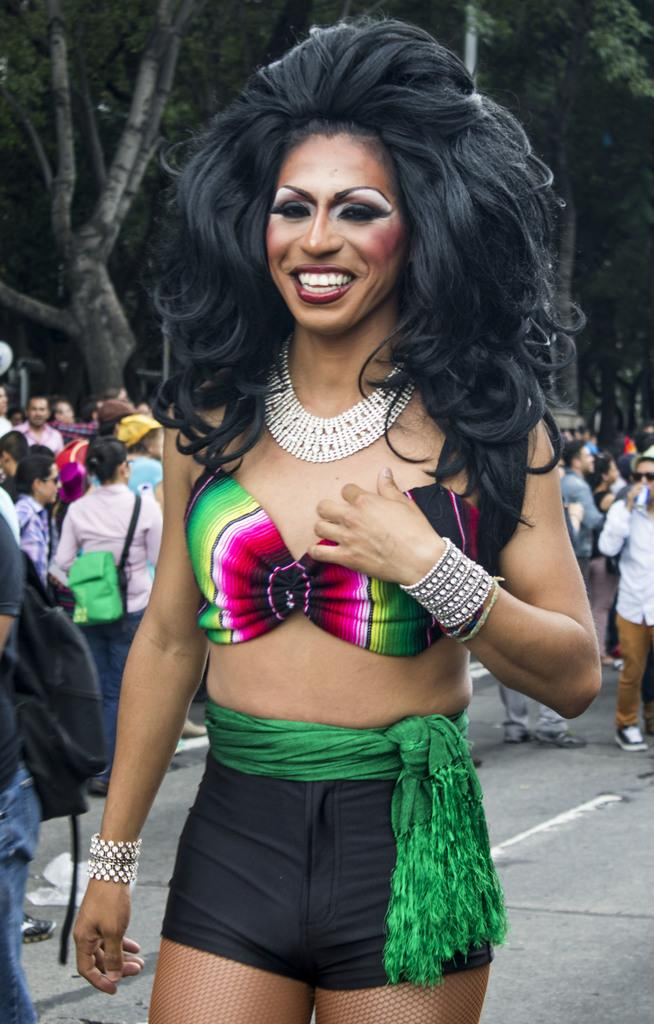Who is the main subject in the image? There is a woman in the image. What is the woman wearing? The woman is wearing a colorful dress. What expression does the woman have? The woman is smiling. What can be seen in the background of the image? There is a crowd of people and a road visible in the background of the image. How many clover leaves are visible on the woman's dress in the image? There are no clover leaves visible on the woman's dress in the image. What type of wing can be seen on the woman's back in the image? There is no wing visible on the woman's back in the image. 